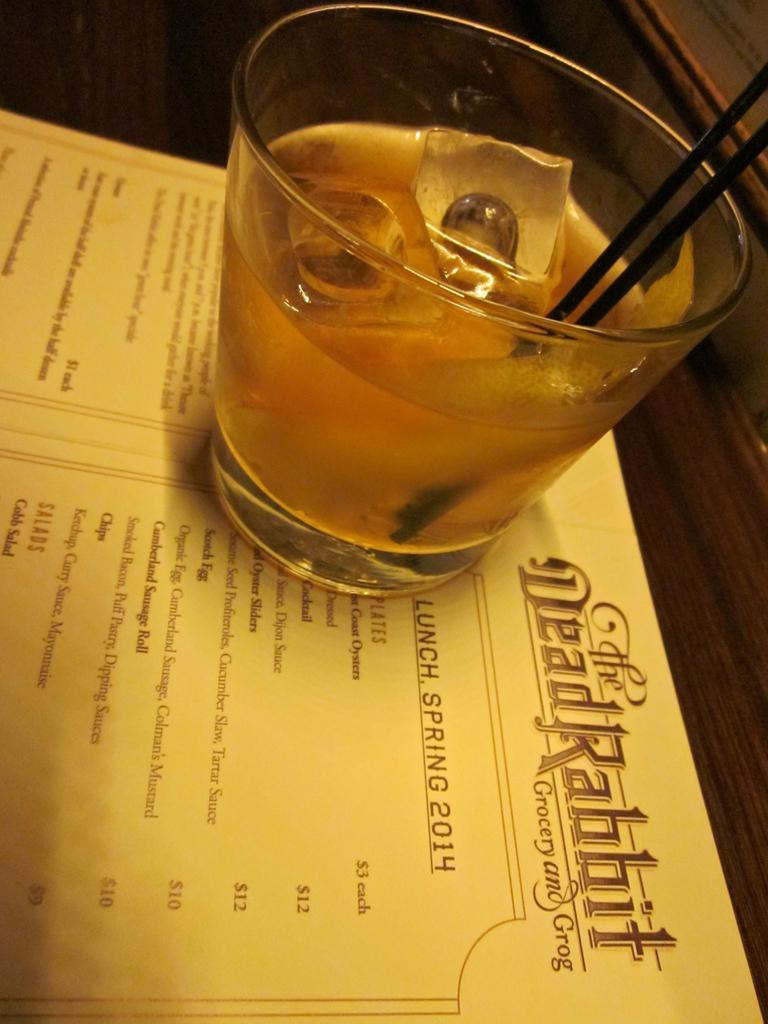<image>
Present a compact description of the photo's key features. A menu from The Dead Rabbit is open and has a drink sitting on top of it. 